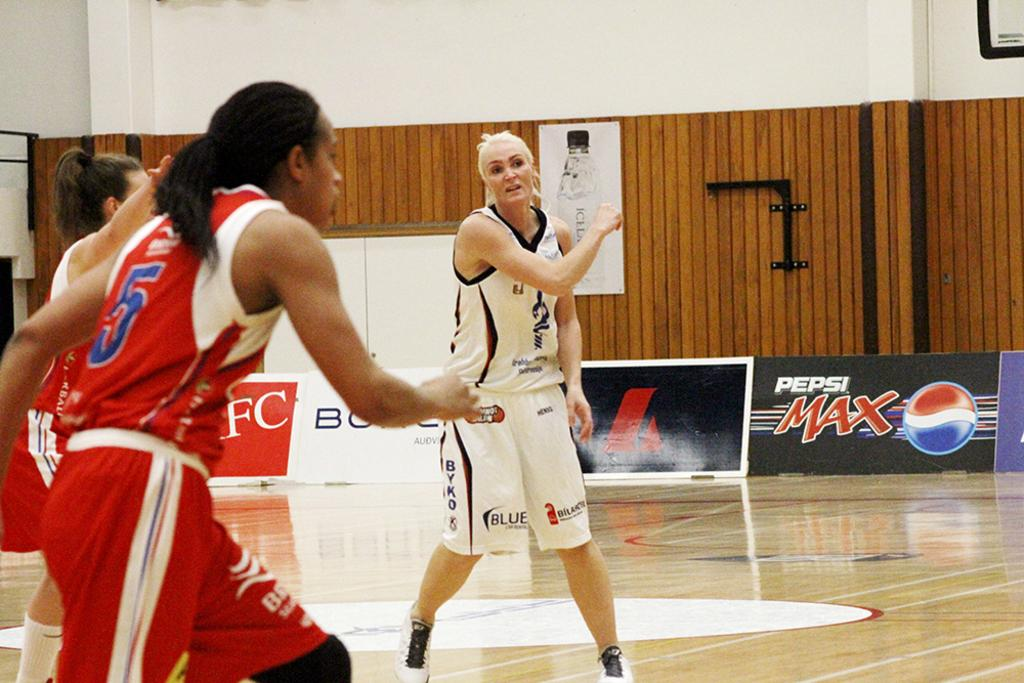<image>
Give a short and clear explanation of the subsequent image. Basketball play number two in white playing number 5 in red 